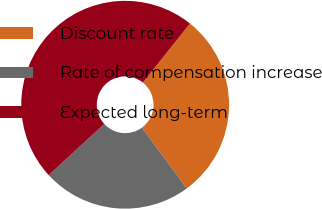Convert chart. <chart><loc_0><loc_0><loc_500><loc_500><pie_chart><fcel>Discount rate<fcel>Rate of compensation increase<fcel>Expected long-term<nl><fcel>29.18%<fcel>23.26%<fcel>47.56%<nl></chart> 